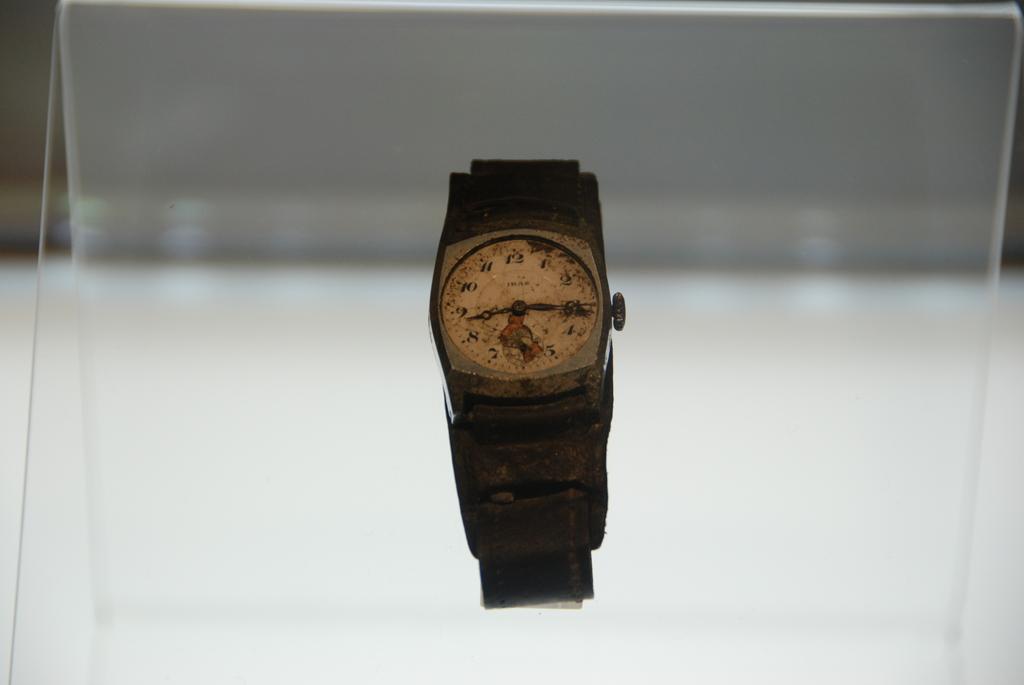In one or two sentences, can you explain what this image depicts? In the foreground of this image, there is a watch and we can also see the glass. 